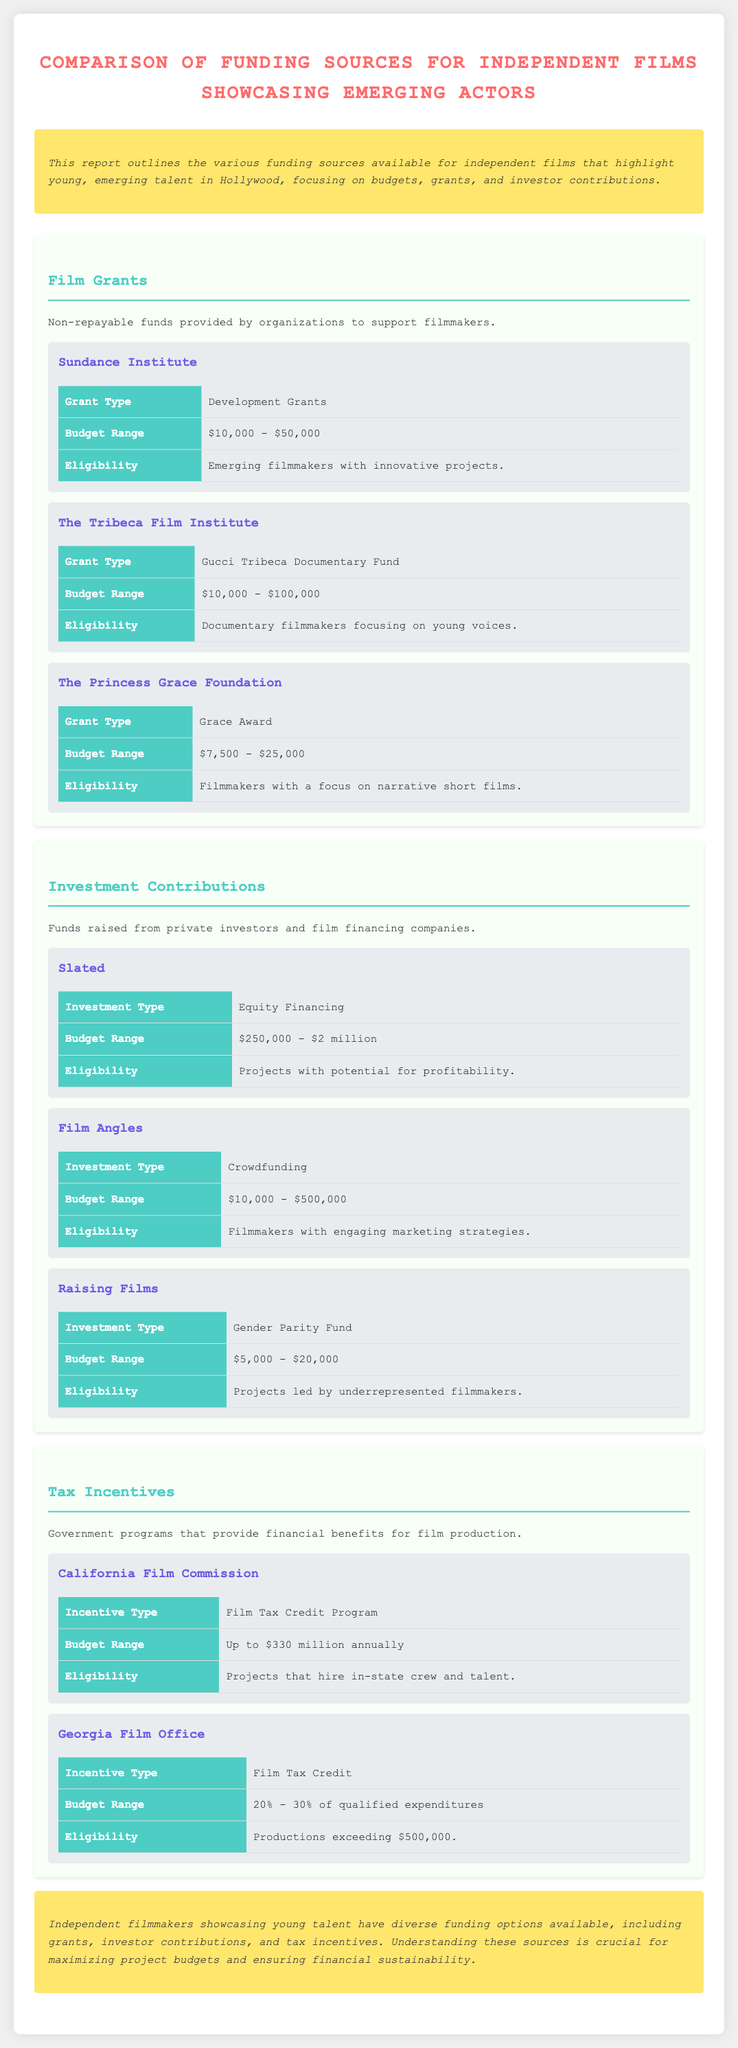What is the budget range for Sundance Institute grants? The budget range is detailed in the document under the Sundance Institute section, which states it ranges from $10,000 to $50,000.
Answer: $10,000 - $50,000 What type of funding does Slated provide? The document specifies that Slated offers equity financing as its investment type for filmmakers.
Answer: Equity Financing What is the eligibility criterion for The Tribeca Film Institute grants? The eligibility requirement outlined in the document indicates that it is for documentary filmmakers focusing on young voices.
Answer: Documentary filmmakers focusing on young voices What is the budget range for the California Film Commission tax incentive? According to the document, the budget range for the California Film Commission is stated to be up to $330 million annually.
Answer: Up to $330 million annually Name one funding source that supports projects led by underrepresented filmmakers. The document lists Raising Films as a funding source that offers a Gender Parity Fund specifically for this purpose.
Answer: Raising Films How much can filmmakers potentially raise through crowdfunding according to Film Angles? The budget range for crowdfunding through Film Angles as per the document is between $10,000 and $500,000.
Answer: $10,000 - $500,000 What is the conclusion regarding independent filmmakers showcasing young talent? The conclusion states that independent filmmakers have diverse funding options and understanding these is crucial for financial sustainability.
Answer: Diverse funding options What grant type is offered by The Princess Grace Foundation? The document indicates that The Princess Grace Foundation offers the Grace Award grant type for filmmakers.
Answer: Grace Award 